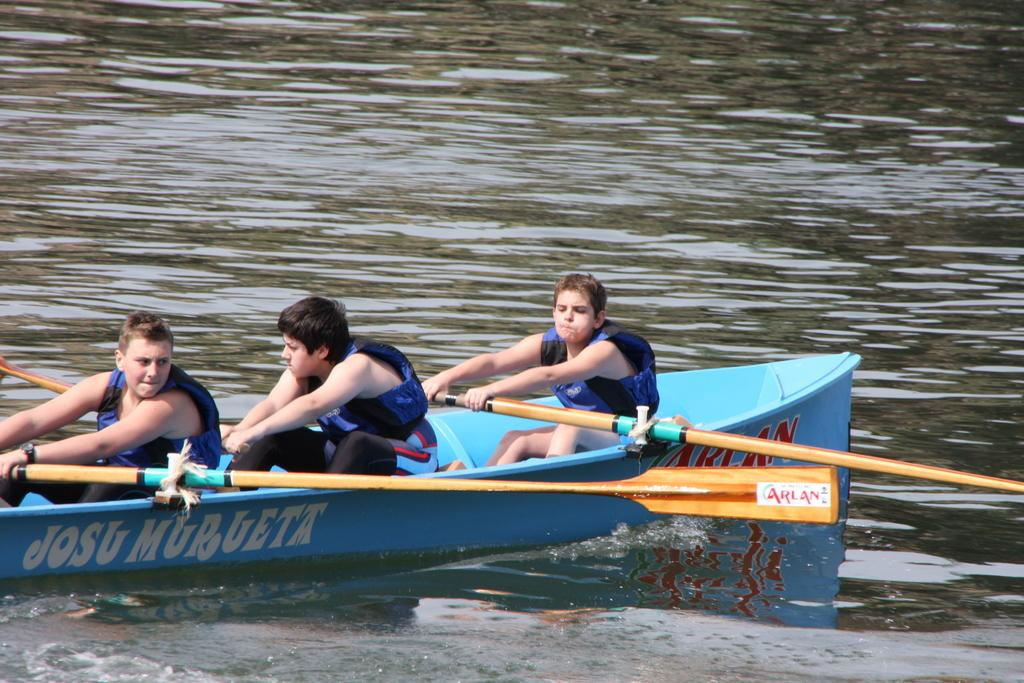How many people are in the boat in the image? There are three people in the boat. What are the people in the boat holding? The people are holding paddles. What activity are the people likely engaged in? The people are likely rowing the boat. Where is the boat located? The boat is on the water. Can you see any ants crawling on the people in the boat? There are no ants visible in the image. What type of vest is the person in the middle of the boat wearing? There is no vest visible on any of the people in the boat. 